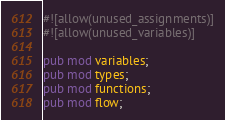<code> <loc_0><loc_0><loc_500><loc_500><_Rust_>#![allow(unused_assignments)]
#![allow(unused_variables)]

pub mod variables;
pub mod types;
pub mod functions;
pub mod flow;</code> 